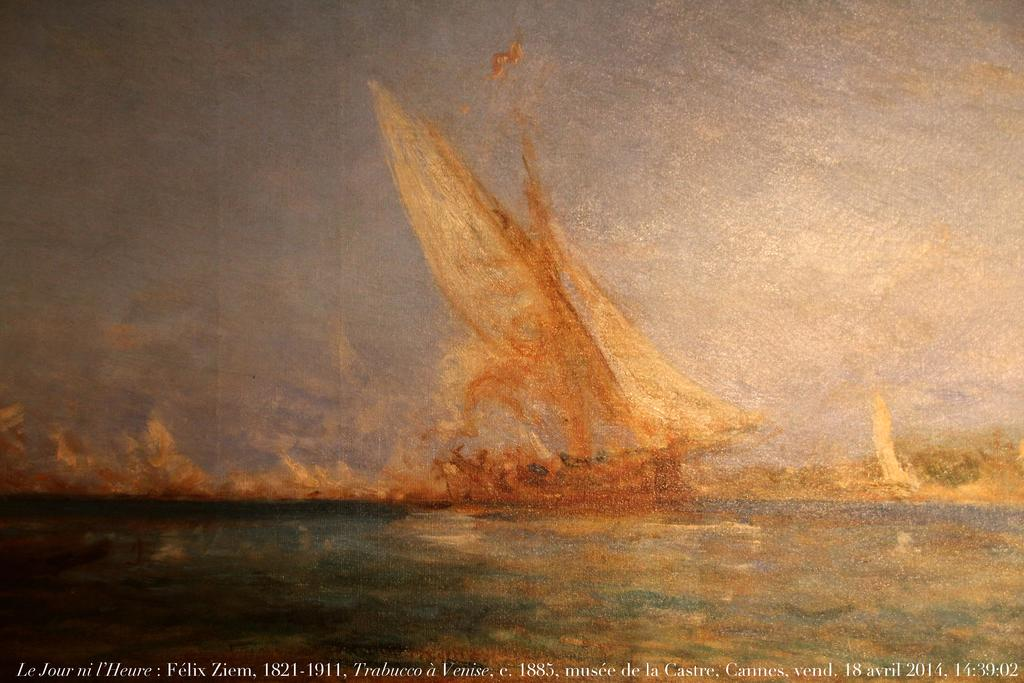Provide a one-sentence caption for the provided image. A painting is dated April 18, 2014 and identified with a location of Cannes. 